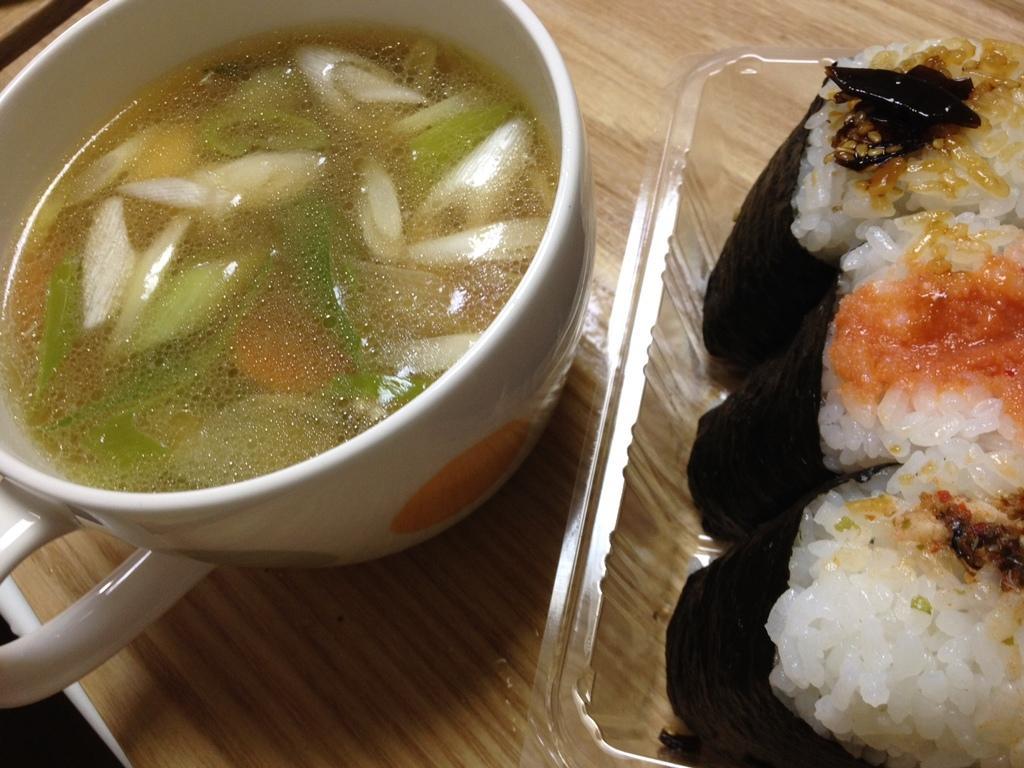In one or two sentences, can you explain what this image depicts? In this image I can see the cream and brown colored surface and on it I can see a plastic box with few food items in it and a white colored bowl with soup in it. 